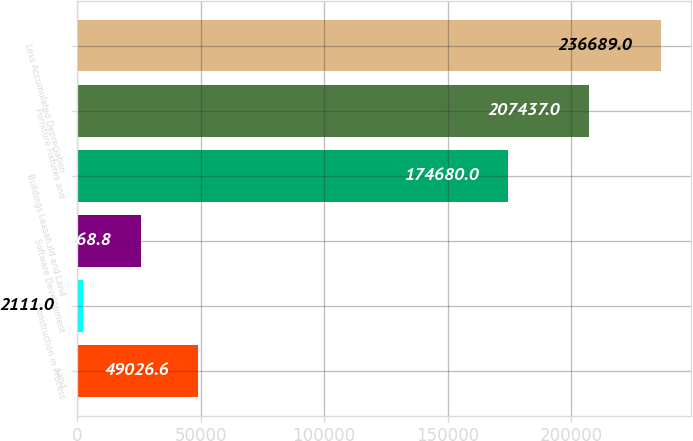<chart> <loc_0><loc_0><loc_500><loc_500><bar_chart><fcel>Land<fcel>Construction in Process<fcel>Software Development<fcel>Buildings Leasehold and Land<fcel>Furniture Fixtures and<fcel>Less Accumulated Depreciation<nl><fcel>49026.6<fcel>2111<fcel>25568.8<fcel>174680<fcel>207437<fcel>236689<nl></chart> 